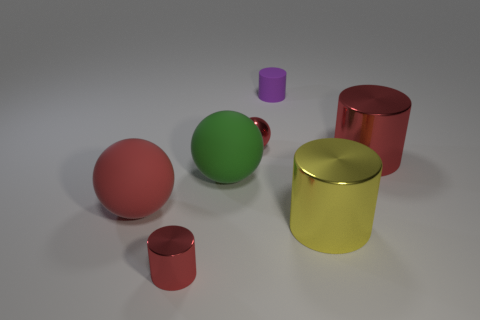Subtract all yellow cylinders. How many cylinders are left? 3 Subtract all red balls. How many balls are left? 1 Add 3 yellow metal objects. How many objects exist? 10 Subtract 2 cylinders. How many cylinders are left? 2 Add 4 tiny balls. How many tiny balls exist? 5 Subtract 0 cyan spheres. How many objects are left? 7 Subtract all cylinders. How many objects are left? 3 Subtract all yellow spheres. Subtract all purple blocks. How many spheres are left? 3 Subtract all red cylinders. How many red balls are left? 2 Subtract all big matte balls. Subtract all big yellow shiny cylinders. How many objects are left? 4 